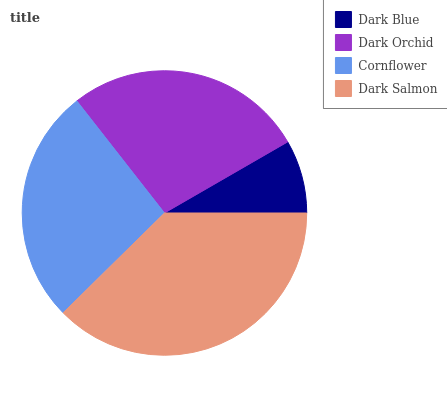Is Dark Blue the minimum?
Answer yes or no. Yes. Is Dark Salmon the maximum?
Answer yes or no. Yes. Is Dark Orchid the minimum?
Answer yes or no. No. Is Dark Orchid the maximum?
Answer yes or no. No. Is Dark Orchid greater than Dark Blue?
Answer yes or no. Yes. Is Dark Blue less than Dark Orchid?
Answer yes or no. Yes. Is Dark Blue greater than Dark Orchid?
Answer yes or no. No. Is Dark Orchid less than Dark Blue?
Answer yes or no. No. Is Dark Orchid the high median?
Answer yes or no. Yes. Is Cornflower the low median?
Answer yes or no. Yes. Is Dark Salmon the high median?
Answer yes or no. No. Is Dark Orchid the low median?
Answer yes or no. No. 